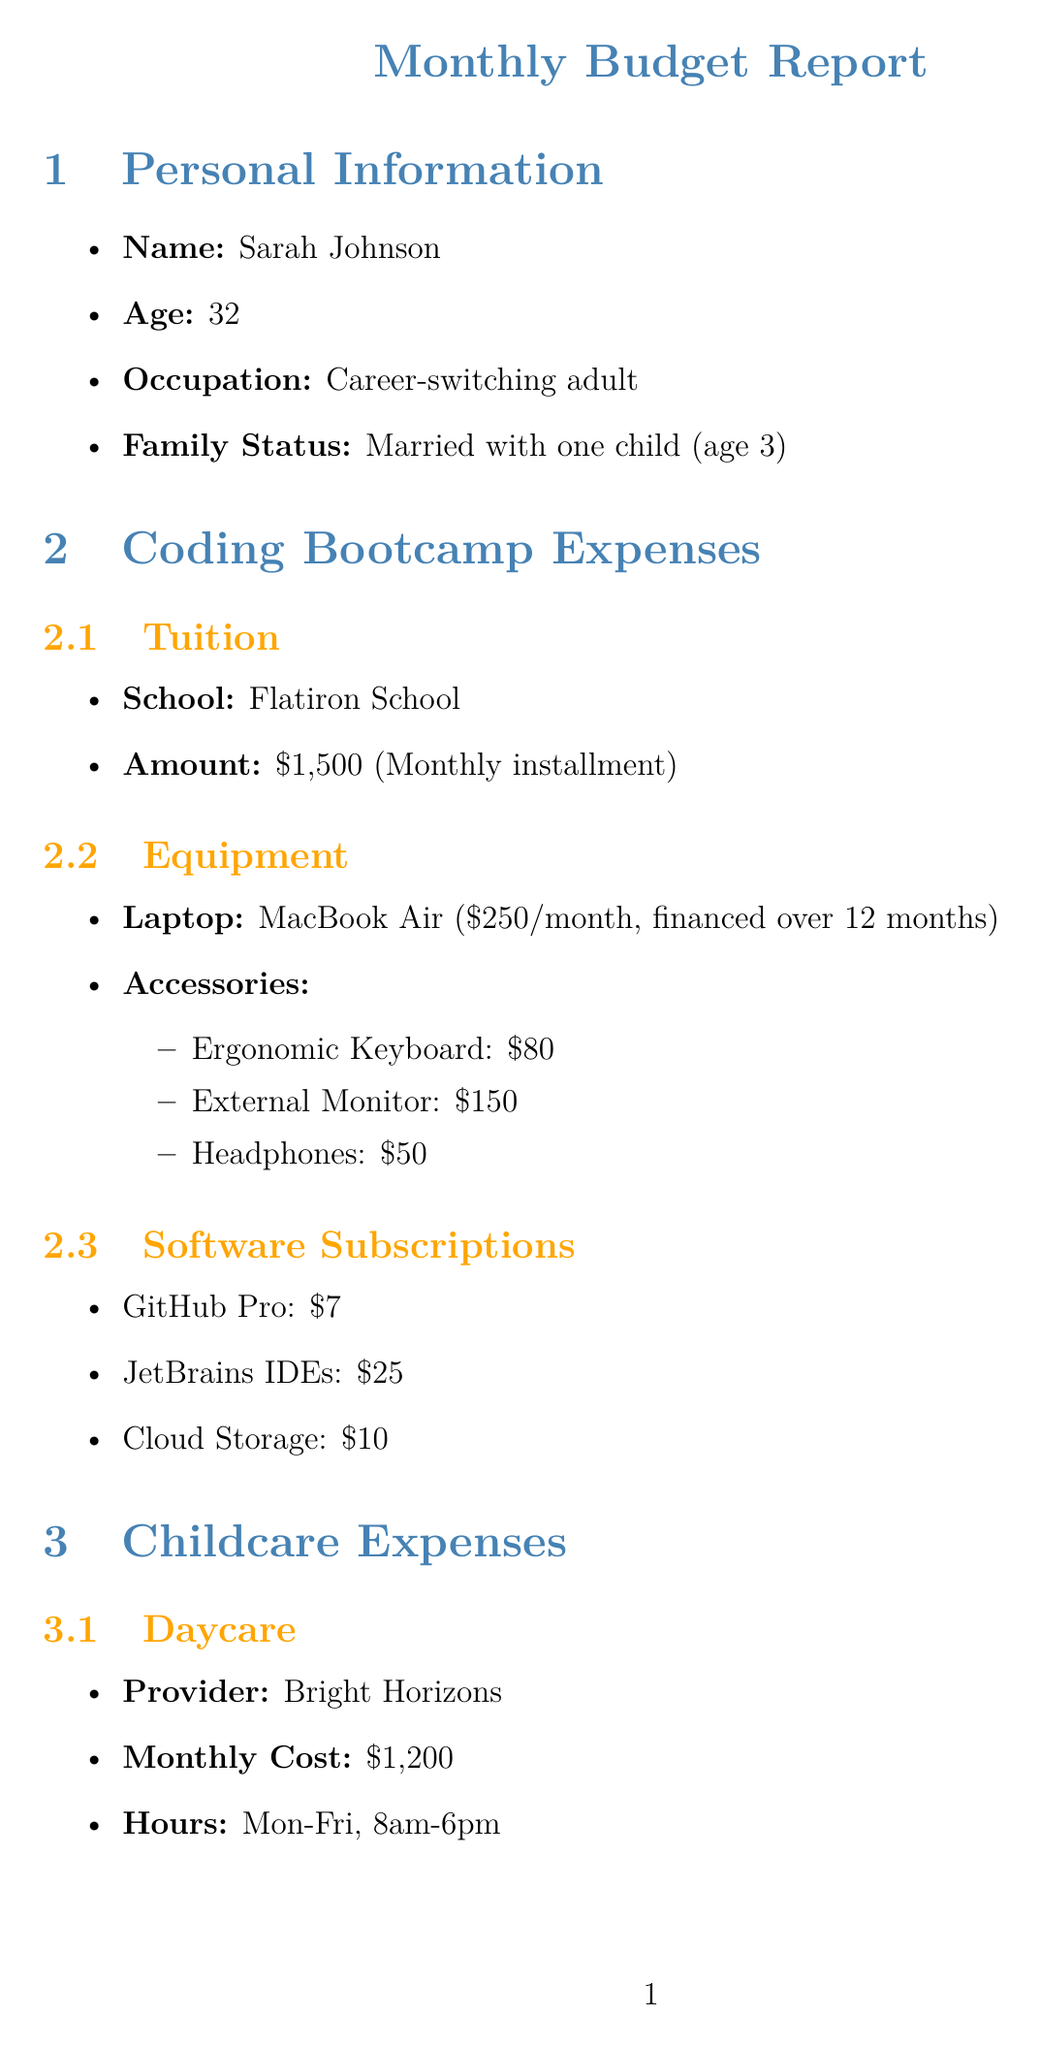What is the monthly tuition for the coding bootcamp? The monthly tuition for the coding bootcamp is listed under the coding bootcamp expenses section, which states it is $1500.
Answer: $1500 What is the average monthly cost for babysitting? The document provides information about babysitting costs under childcare expenses, stating the average cost per month is $200.
Answer: $200 How much is the family's mortgage payment? The mortgage payment is detailed in the household costs section, showing it is $1800.
Answer: $1800 What is the total income of the household? The total income is mentioned in the budget summary and is calculated as $7300.
Answer: $7300 How much is allocated for the emergency fund? The emergency fund amount is specified in the savings and investments section, indicating an allocation of $200.
Answer: $200 What is the frequency of monthly date nights? The frequency of monthly date nights is stated in the stress management strategies, mentioning they are budgeted into babysitting expenses.
Answer: Monthly What is the total amount spent on groceries? Groceries are categorized under other expenses, with the document indicating a total expenditure of $600.
Answer: $600 What are the names of the budgeting tools used? The budgeting tools section lists the specific tools being used, including YNAB, Chase, and Ally Bank.
Answer: YNAB, Chase, Ally Bank Which school is Sarah attending for her coding bootcamp? The school details are provided in the coding bootcamp expenses section, naming Flatiron School.
Answer: Flatiron School 